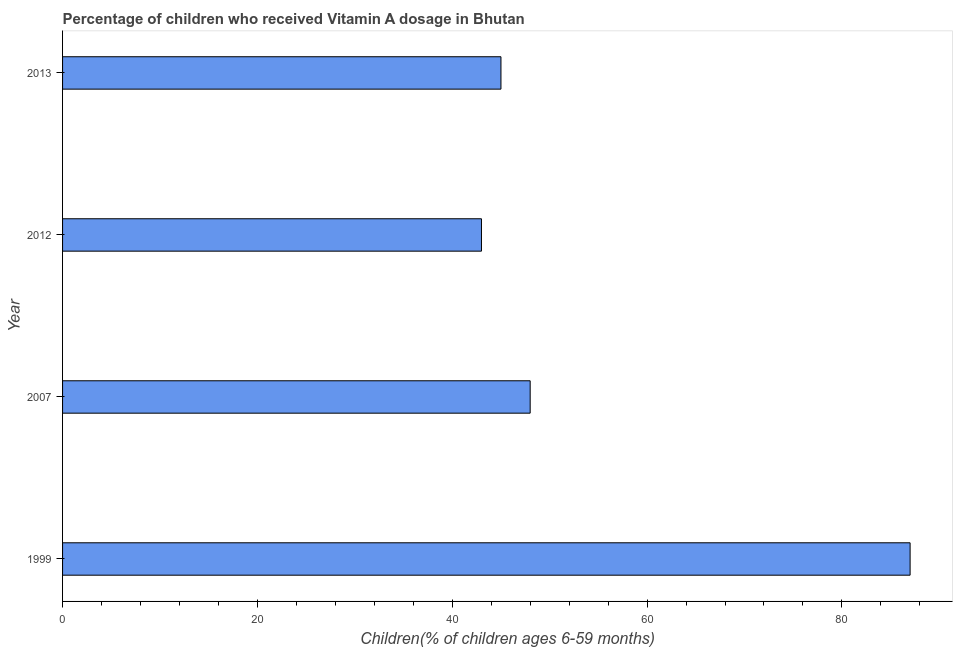What is the title of the graph?
Provide a short and direct response. Percentage of children who received Vitamin A dosage in Bhutan. What is the label or title of the X-axis?
Your answer should be very brief. Children(% of children ages 6-59 months). What is the label or title of the Y-axis?
Your answer should be very brief. Year. What is the sum of the vitamin a supplementation coverage rate?
Keep it short and to the point. 223. What is the average vitamin a supplementation coverage rate per year?
Your answer should be very brief. 55. What is the median vitamin a supplementation coverage rate?
Your answer should be very brief. 46.5. In how many years, is the vitamin a supplementation coverage rate greater than 84 %?
Give a very brief answer. 1. What is the ratio of the vitamin a supplementation coverage rate in 2012 to that in 2013?
Provide a short and direct response. 0.96. What is the difference between the highest and the second highest vitamin a supplementation coverage rate?
Ensure brevity in your answer.  39. Are all the bars in the graph horizontal?
Your answer should be compact. Yes. How many years are there in the graph?
Offer a terse response. 4. What is the difference between two consecutive major ticks on the X-axis?
Provide a short and direct response. 20. Are the values on the major ticks of X-axis written in scientific E-notation?
Make the answer very short. No. What is the Children(% of children ages 6-59 months) of 2012?
Your answer should be very brief. 43. What is the Children(% of children ages 6-59 months) of 2013?
Your response must be concise. 45. What is the difference between the Children(% of children ages 6-59 months) in 1999 and 2007?
Make the answer very short. 39. What is the difference between the Children(% of children ages 6-59 months) in 1999 and 2012?
Provide a short and direct response. 44. What is the difference between the Children(% of children ages 6-59 months) in 1999 and 2013?
Offer a terse response. 42. What is the difference between the Children(% of children ages 6-59 months) in 2007 and 2012?
Provide a succinct answer. 5. What is the difference between the Children(% of children ages 6-59 months) in 2007 and 2013?
Offer a terse response. 3. What is the difference between the Children(% of children ages 6-59 months) in 2012 and 2013?
Give a very brief answer. -2. What is the ratio of the Children(% of children ages 6-59 months) in 1999 to that in 2007?
Keep it short and to the point. 1.81. What is the ratio of the Children(% of children ages 6-59 months) in 1999 to that in 2012?
Your answer should be compact. 2.02. What is the ratio of the Children(% of children ages 6-59 months) in 1999 to that in 2013?
Your response must be concise. 1.93. What is the ratio of the Children(% of children ages 6-59 months) in 2007 to that in 2012?
Ensure brevity in your answer.  1.12. What is the ratio of the Children(% of children ages 6-59 months) in 2007 to that in 2013?
Make the answer very short. 1.07. What is the ratio of the Children(% of children ages 6-59 months) in 2012 to that in 2013?
Offer a very short reply. 0.96. 